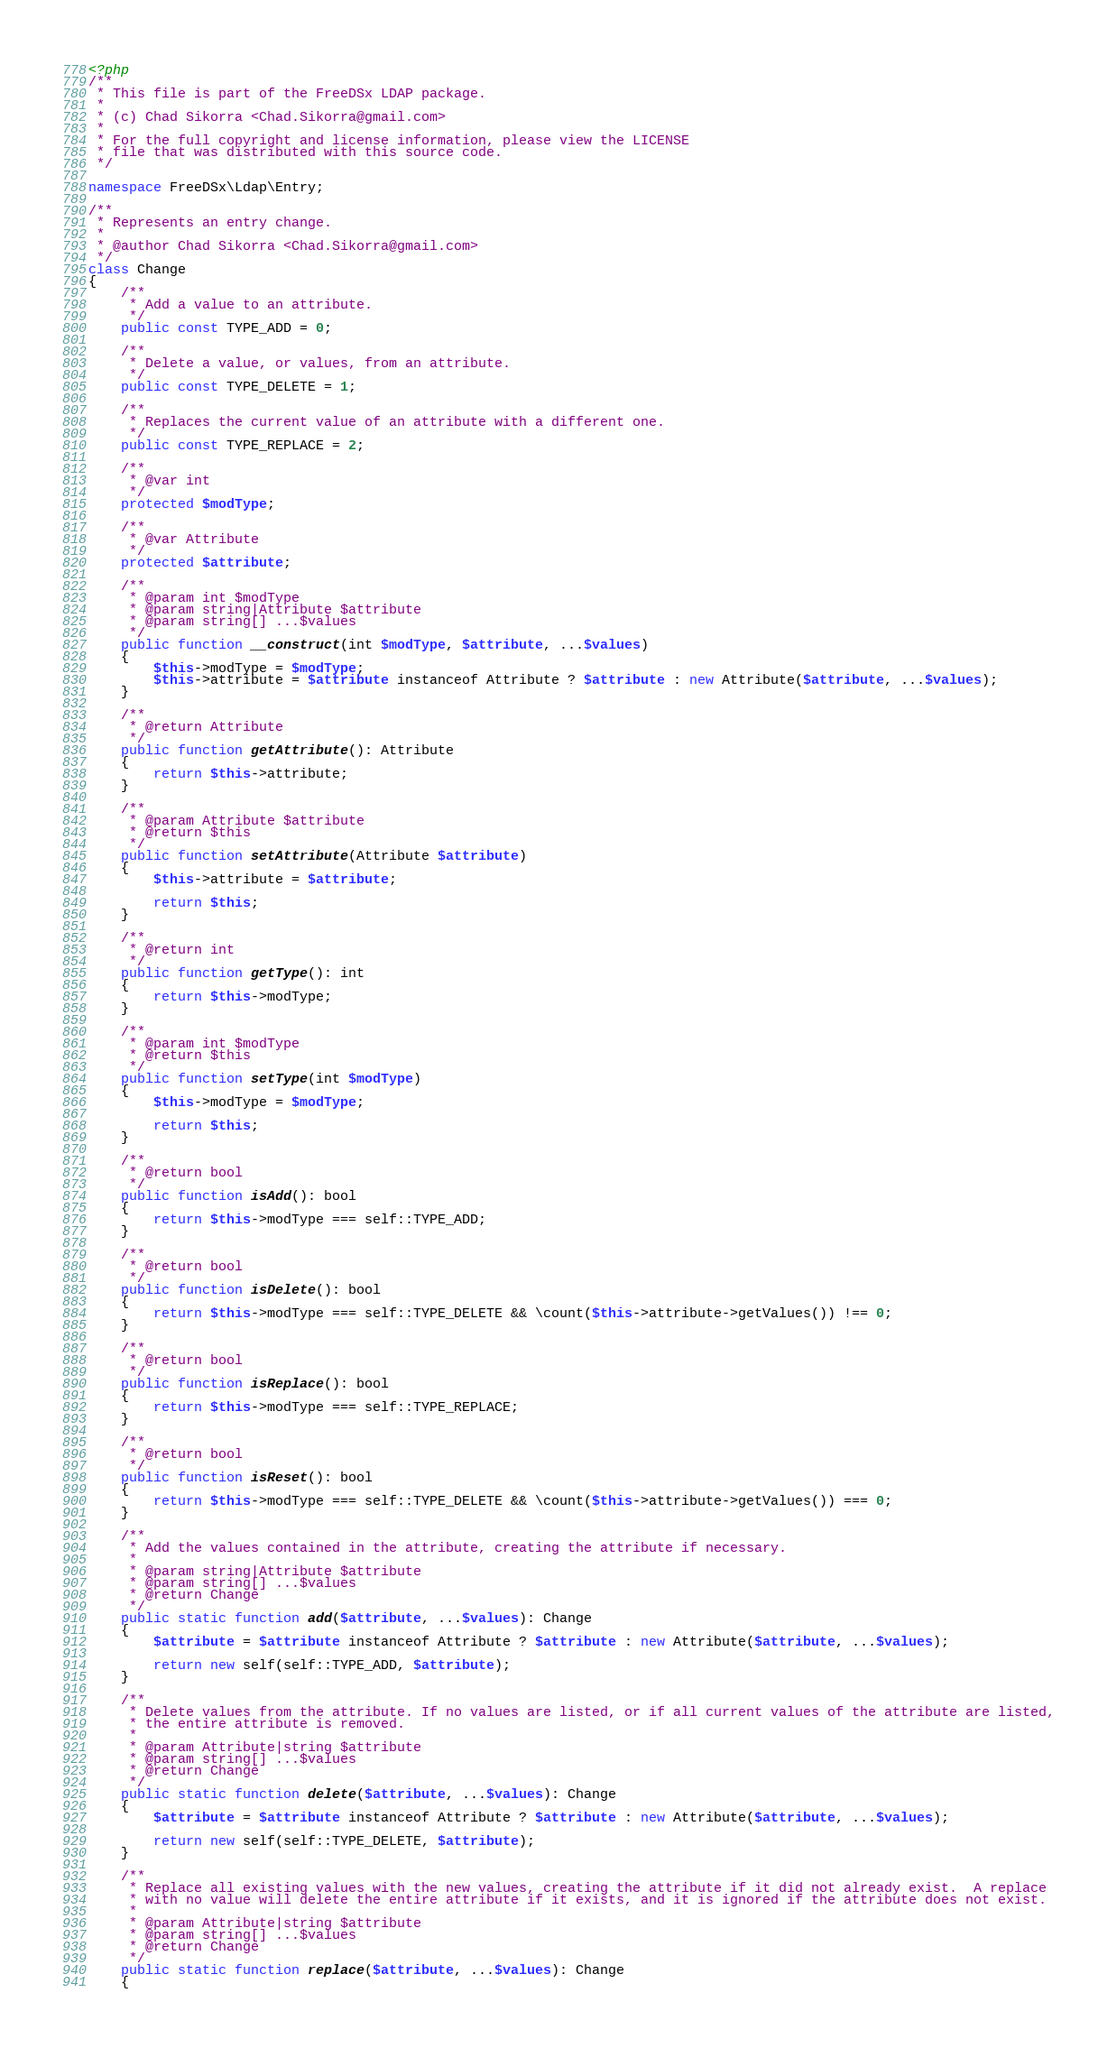<code> <loc_0><loc_0><loc_500><loc_500><_PHP_><?php
/**
 * This file is part of the FreeDSx LDAP package.
 *
 * (c) Chad Sikorra <Chad.Sikorra@gmail.com>
 *
 * For the full copyright and license information, please view the LICENSE
 * file that was distributed with this source code.
 */

namespace FreeDSx\Ldap\Entry;

/**
 * Represents an entry change.
 *
 * @author Chad Sikorra <Chad.Sikorra@gmail.com>
 */
class Change
{
    /**
     * Add a value to an attribute.
     */
    public const TYPE_ADD = 0;

    /**
     * Delete a value, or values, from an attribute.
     */
    public const TYPE_DELETE = 1;

    /**
     * Replaces the current value of an attribute with a different one.
     */
    public const TYPE_REPLACE = 2;

    /**
     * @var int
     */
    protected $modType;

    /**
     * @var Attribute
     */
    protected $attribute;

    /**
     * @param int $modType
     * @param string|Attribute $attribute
     * @param string[] ...$values
     */
    public function __construct(int $modType, $attribute, ...$values)
    {
        $this->modType = $modType;
        $this->attribute = $attribute instanceof Attribute ? $attribute : new Attribute($attribute, ...$values);
    }

    /**
     * @return Attribute
     */
    public function getAttribute(): Attribute
    {
        return $this->attribute;
    }

    /**
     * @param Attribute $attribute
     * @return $this
     */
    public function setAttribute(Attribute $attribute)
    {
        $this->attribute = $attribute;

        return $this;
    }

    /**
     * @return int
     */
    public function getType(): int
    {
        return $this->modType;
    }

    /**
     * @param int $modType
     * @return $this
     */
    public function setType(int $modType)
    {
        $this->modType = $modType;

        return $this;
    }

    /**
     * @return bool
     */
    public function isAdd(): bool
    {
        return $this->modType === self::TYPE_ADD;
    }

    /**
     * @return bool
     */
    public function isDelete(): bool
    {
        return $this->modType === self::TYPE_DELETE && \count($this->attribute->getValues()) !== 0;
    }

    /**
     * @return bool
     */
    public function isReplace(): bool
    {
        return $this->modType === self::TYPE_REPLACE;
    }

    /**
     * @return bool
     */
    public function isReset(): bool
    {
        return $this->modType === self::TYPE_DELETE && \count($this->attribute->getValues()) === 0;
    }

    /**
     * Add the values contained in the attribute, creating the attribute if necessary.
     *
     * @param string|Attribute $attribute
     * @param string[] ...$values
     * @return Change
     */
    public static function add($attribute, ...$values): Change
    {
        $attribute = $attribute instanceof Attribute ? $attribute : new Attribute($attribute, ...$values);

        return new self(self::TYPE_ADD, $attribute);
    }

    /**
     * Delete values from the attribute. If no values are listed, or if all current values of the attribute are listed,
     * the entire attribute is removed.
     *
     * @param Attribute|string $attribute
     * @param string[] ...$values
     * @return Change
     */
    public static function delete($attribute, ...$values): Change
    {
        $attribute = $attribute instanceof Attribute ? $attribute : new Attribute($attribute, ...$values);

        return new self(self::TYPE_DELETE, $attribute);
    }

    /**
     * Replace all existing values with the new values, creating the attribute if it did not already exist.  A replace
     * with no value will delete the entire attribute if it exists, and it is ignored if the attribute does not exist.
     *
     * @param Attribute|string $attribute
     * @param string[] ...$values
     * @return Change
     */
    public static function replace($attribute, ...$values): Change
    {</code> 